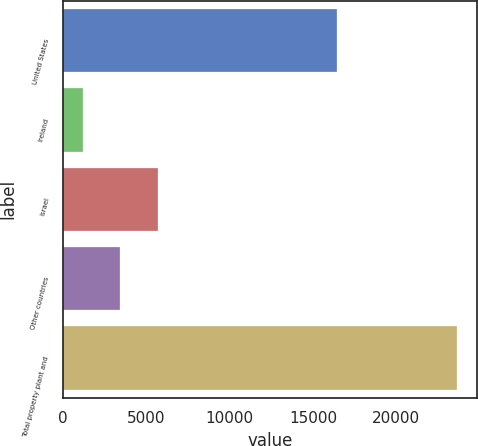Convert chart. <chart><loc_0><loc_0><loc_500><loc_500><bar_chart><fcel>United States<fcel>Ireland<fcel>Israel<fcel>Other countries<fcel>Total property plant and<nl><fcel>16448<fcel>1198<fcel>5683.8<fcel>3440.9<fcel>23627<nl></chart> 